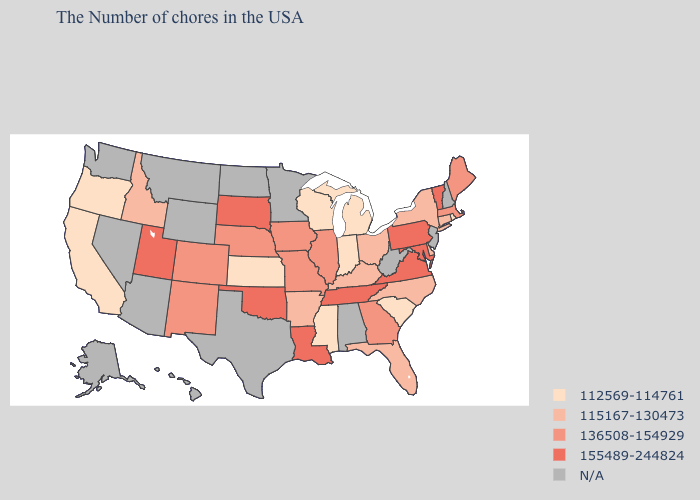What is the lowest value in states that border Vermont?
Concise answer only. 115167-130473. What is the lowest value in states that border Delaware?
Be succinct. 155489-244824. Is the legend a continuous bar?
Short answer required. No. Among the states that border Wisconsin , does Michigan have the highest value?
Short answer required. No. What is the value of Minnesota?
Short answer required. N/A. Which states hav the highest value in the South?
Quick response, please. Maryland, Virginia, Tennessee, Louisiana, Oklahoma. What is the highest value in the USA?
Quick response, please. 155489-244824. What is the value of New Jersey?
Short answer required. N/A. What is the value of Georgia?
Quick response, please. 136508-154929. Which states have the highest value in the USA?
Answer briefly. Vermont, Maryland, Pennsylvania, Virginia, Tennessee, Louisiana, Oklahoma, South Dakota, Utah. Name the states that have a value in the range 155489-244824?
Be succinct. Vermont, Maryland, Pennsylvania, Virginia, Tennessee, Louisiana, Oklahoma, South Dakota, Utah. Does Utah have the lowest value in the West?
Concise answer only. No. Name the states that have a value in the range 112569-114761?
Concise answer only. Rhode Island, South Carolina, Michigan, Indiana, Wisconsin, Mississippi, Kansas, California, Oregon. Name the states that have a value in the range 115167-130473?
Concise answer only. Connecticut, New York, Delaware, North Carolina, Ohio, Florida, Kentucky, Arkansas, Idaho. What is the value of Vermont?
Be succinct. 155489-244824. 